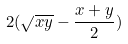Convert formula to latex. <formula><loc_0><loc_0><loc_500><loc_500>2 ( \sqrt { x y } - \frac { x + y } { 2 } )</formula> 